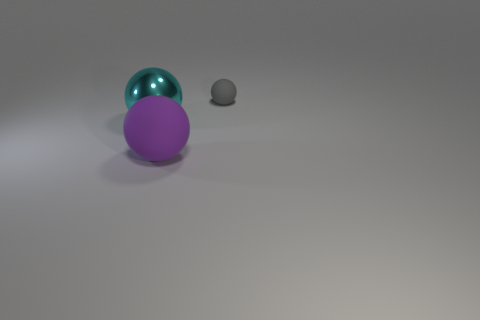What number of large things are purple balls or cyan metal spheres?
Give a very brief answer. 2. What color is the object that is to the right of the large shiny object and in front of the tiny gray sphere?
Give a very brief answer. Purple. Is the material of the purple sphere the same as the big cyan thing?
Your answer should be very brief. No. The gray matte thing has what shape?
Your answer should be compact. Sphere. How many rubber spheres are left of the rubber object in front of the large sphere that is left of the purple object?
Offer a terse response. 0. The other metallic thing that is the same shape as the gray thing is what color?
Keep it short and to the point. Cyan. The rubber thing that is to the left of the ball on the right side of the matte sphere that is left of the tiny gray ball is what shape?
Offer a terse response. Sphere. There is a ball that is both behind the big purple ball and to the left of the tiny gray rubber ball; what is its size?
Offer a very short reply. Large. Are there fewer small objects than green rubber blocks?
Provide a short and direct response. No. There is a thing that is behind the cyan shiny sphere; how big is it?
Offer a very short reply. Small. 